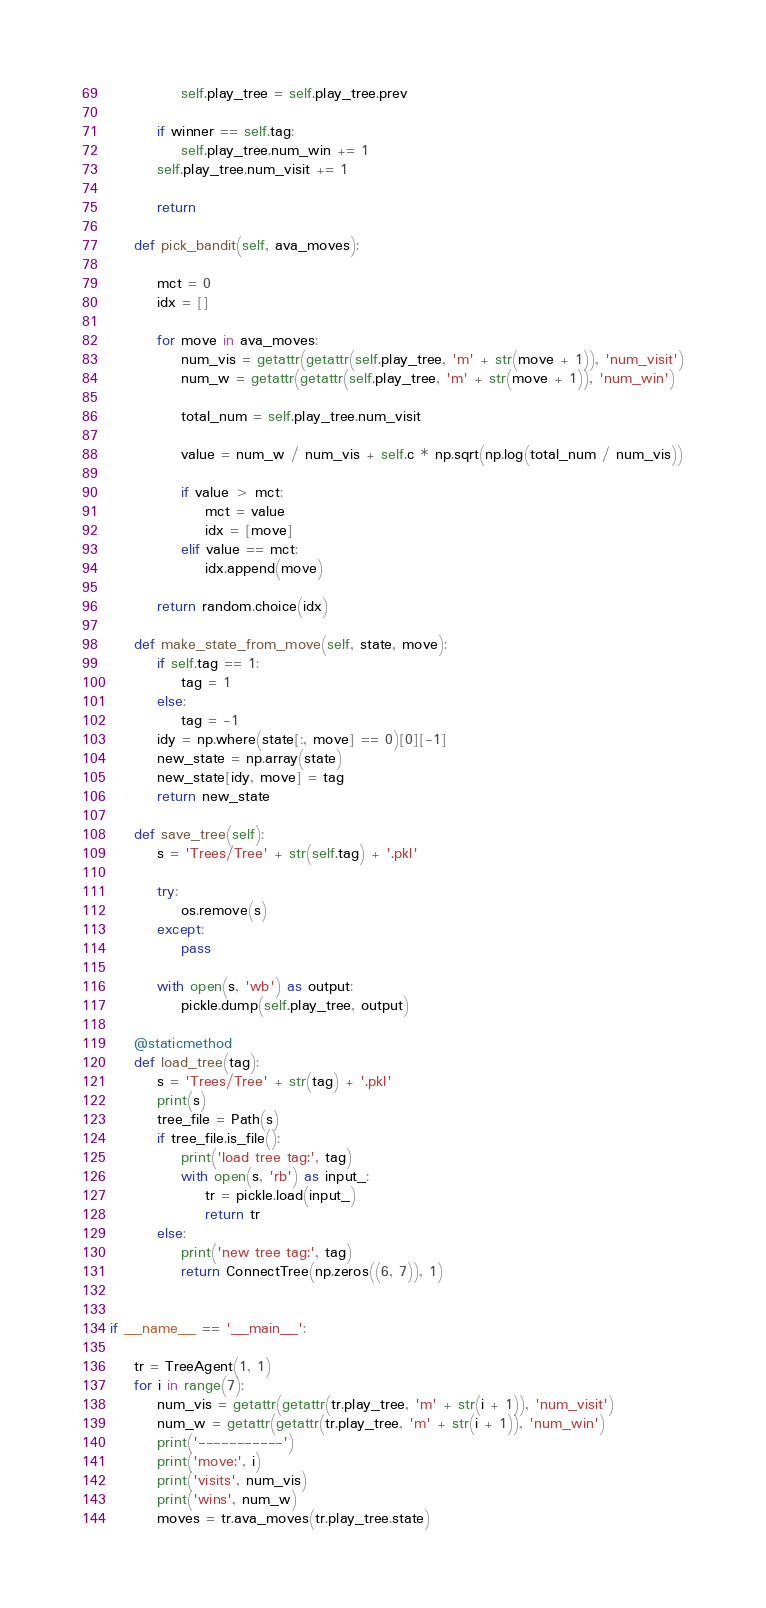<code> <loc_0><loc_0><loc_500><loc_500><_Python_>            self.play_tree = self.play_tree.prev

        if winner == self.tag:
            self.play_tree.num_win += 1
        self.play_tree.num_visit += 1

        return

    def pick_bandit(self, ava_moves):

        mct = 0
        idx = []

        for move in ava_moves:
            num_vis = getattr(getattr(self.play_tree, 'm' + str(move + 1)), 'num_visit')
            num_w = getattr(getattr(self.play_tree, 'm' + str(move + 1)), 'num_win')

            total_num = self.play_tree.num_visit

            value = num_w / num_vis + self.c * np.sqrt(np.log(total_num / num_vis))

            if value > mct:
                mct = value
                idx = [move]
            elif value == mct:
                idx.append(move)

        return random.choice(idx)

    def make_state_from_move(self, state, move):
        if self.tag == 1:
            tag = 1
        else:
            tag = -1
        idy = np.where(state[:, move] == 0)[0][-1]
        new_state = np.array(state)
        new_state[idy, move] = tag
        return new_state

    def save_tree(self):
        s = 'Trees/Tree' + str(self.tag) + '.pkl'

        try:
            os.remove(s)
        except:
            pass

        with open(s, 'wb') as output:
            pickle.dump(self.play_tree, output)

    @staticmethod
    def load_tree(tag):
        s = 'Trees/Tree' + str(tag) + '.pkl'
        print(s)
        tree_file = Path(s)
        if tree_file.is_file():
            print('load tree tag:', tag)
            with open(s, 'rb') as input_:
                tr = pickle.load(input_)
                return tr
        else:
            print('new tree tag:', tag)
            return ConnectTree(np.zeros((6, 7)), 1)


if __name__ == '__main__':

    tr = TreeAgent(1, 1)
    for i in range(7):
        num_vis = getattr(getattr(tr.play_tree, 'm' + str(i + 1)), 'num_visit')
        num_w = getattr(getattr(tr.play_tree, 'm' + str(i + 1)), 'num_win')
        print('-----------')
        print('move:', i)
        print('visits', num_vis)
        print('wins', num_w)
        moves = tr.ava_moves(tr.play_tree.state)

</code> 